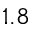Convert formula to latex. <formula><loc_0><loc_0><loc_500><loc_500>1 . 8</formula> 